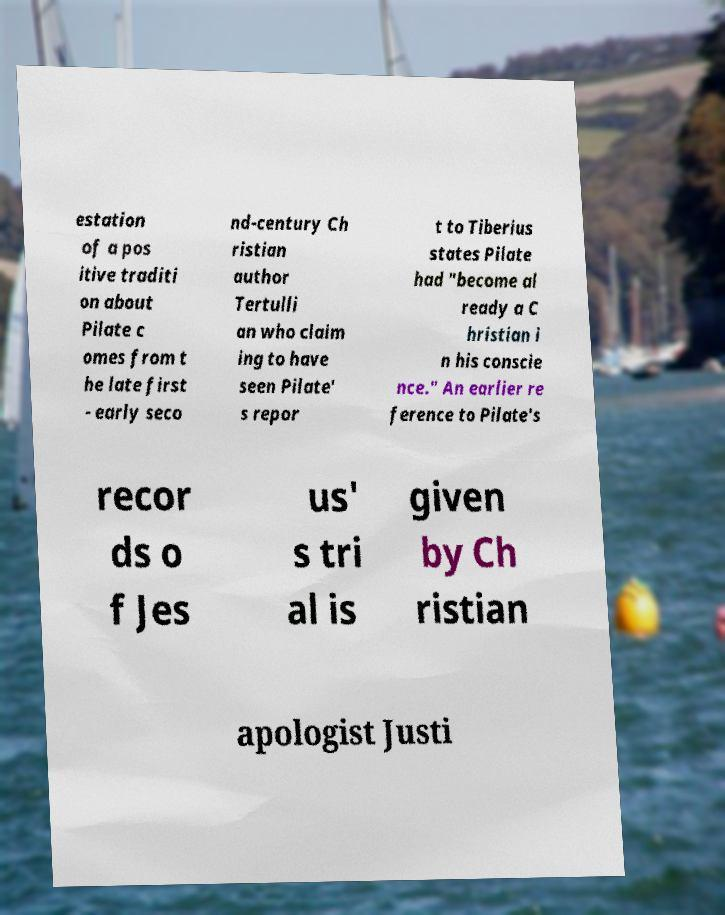Could you assist in decoding the text presented in this image and type it out clearly? estation of a pos itive traditi on about Pilate c omes from t he late first - early seco nd-century Ch ristian author Tertulli an who claim ing to have seen Pilate' s repor t to Tiberius states Pilate had "become al ready a C hristian i n his conscie nce." An earlier re ference to Pilate's recor ds o f Jes us' s tri al is given by Ch ristian apologist Justi 